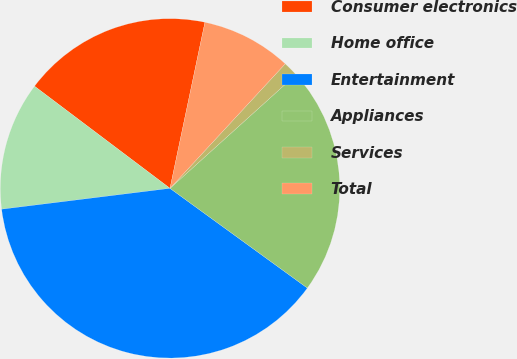<chart> <loc_0><loc_0><loc_500><loc_500><pie_chart><fcel>Consumer electronics<fcel>Home office<fcel>Entertainment<fcel>Appliances<fcel>Services<fcel>Total<nl><fcel>18.02%<fcel>12.24%<fcel>38.04%<fcel>21.68%<fcel>1.43%<fcel>8.58%<nl></chart> 